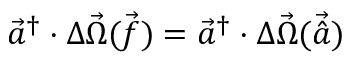Convert formula to latex. <formula><loc_0><loc_0><loc_500><loc_500>\ V e c { a } ^ { \dagger } \cdot \Delta \vec { \Omega } { \ V e c { ( f ) } } = \ V e c { a } ^ { \dagger } \cdot \Delta \vec { \Omega } { \ V e c { ( \hat { a } ) } }</formula> 